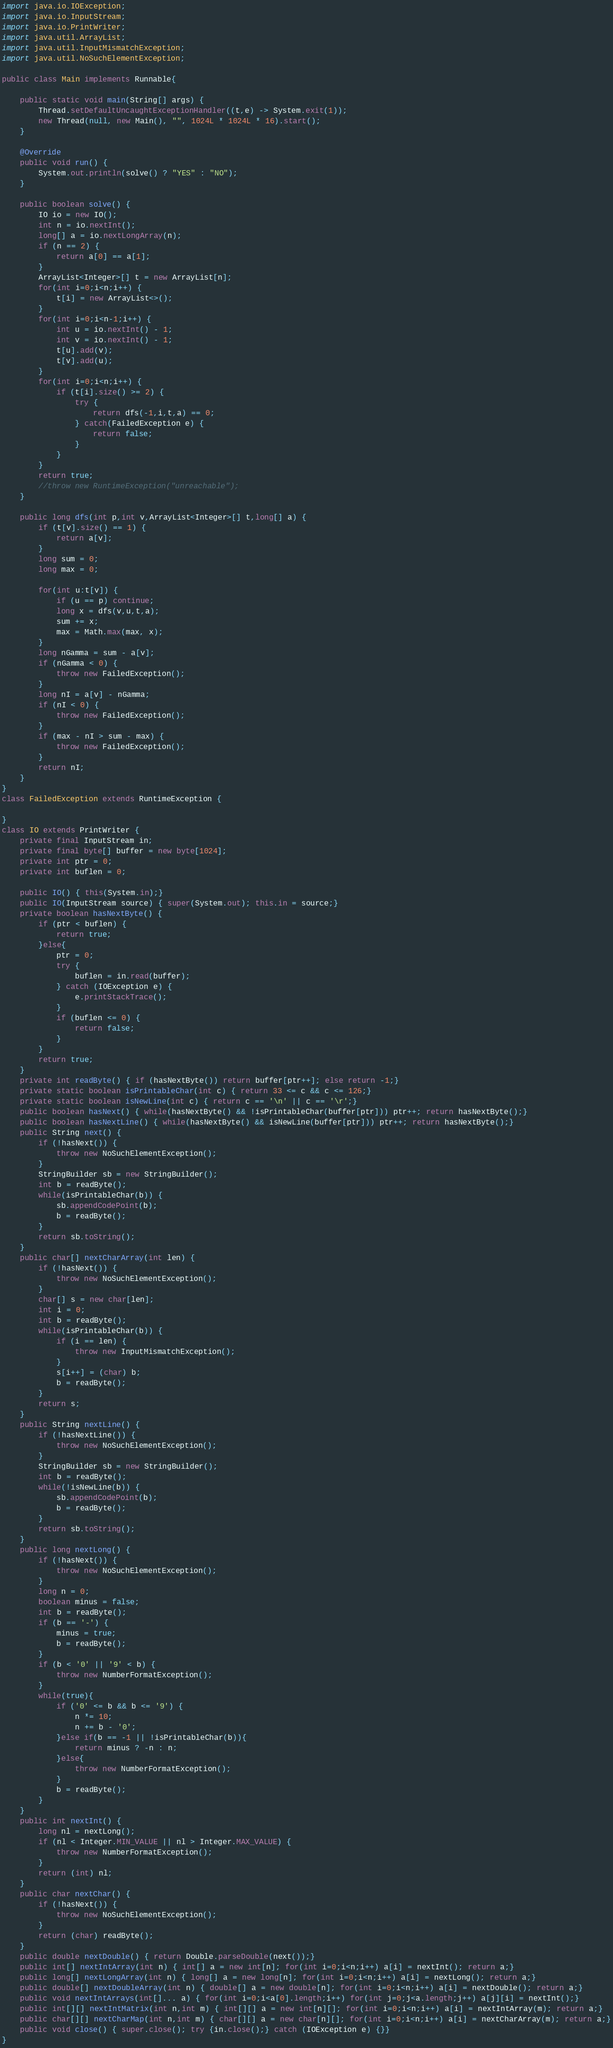<code> <loc_0><loc_0><loc_500><loc_500><_Java_>import java.io.IOException;
import java.io.InputStream;
import java.io.PrintWriter;
import java.util.ArrayList;
import java.util.InputMismatchException;
import java.util.NoSuchElementException;

public class Main implements Runnable{

	public static void main(String[] args) {
		Thread.setDefaultUncaughtExceptionHandler((t,e) -> System.exit(1));
		new Thread(null, new Main(), "", 1024L * 1024L * 16).start();
	}

	@Override
	public void run() {
		System.out.println(solve() ? "YES" : "NO");
	}
	
	public boolean solve() {
		IO io = new IO();
		int n = io.nextInt();
		long[] a = io.nextLongArray(n);
		if (n == 2) {
			return a[0] == a[1];
		}
		ArrayList<Integer>[] t = new ArrayList[n];
		for(int i=0;i<n;i++) {
			t[i] = new ArrayList<>();
		}
		for(int i=0;i<n-1;i++) {
			int u = io.nextInt() - 1;
			int v = io.nextInt() - 1;
			t[u].add(v);
			t[v].add(u);
		}
		for(int i=0;i<n;i++) {
			if (t[i].size() >= 2) {
				try {
					return dfs(-1,i,t,a) == 0;
				} catch(FailedException e) {
					return false;
				}
			}
		}
		return true;
		//throw new RuntimeException("unreachable");
	}
	
	public long dfs(int p,int v,ArrayList<Integer>[] t,long[] a) {
		if (t[v].size() == 1) {
			return a[v];
		}
		long sum = 0;
		long max = 0;
		
		for(int u:t[v]) {
			if (u == p) continue;
			long x = dfs(v,u,t,a);
			sum += x; 
			max = Math.max(max, x);
		}
		long nGamma = sum - a[v];
		if (nGamma < 0) {
			throw new FailedException();
		}
		long nI = a[v] - nGamma;
		if (nI < 0) {
			throw new FailedException();
		}
		if (max - nI > sum - max) {
			throw new FailedException();
		}
		return nI;
	}
}
class FailedException extends RuntimeException {
	
}
class IO extends PrintWriter {
	private final InputStream in;
	private final byte[] buffer = new byte[1024];
	private int ptr = 0;
	private int buflen = 0;
	
	public IO() { this(System.in);}
	public IO(InputStream source) { super(System.out); this.in = source;}
	private boolean hasNextByte() {
		if (ptr < buflen) {
			return true;
		}else{
			ptr = 0;
			try {
				buflen = in.read(buffer);
			} catch (IOException e) {
				e.printStackTrace();
			}
			if (buflen <= 0) {
				return false;
			}
		}
		return true;
	}
	private int readByte() { if (hasNextByte()) return buffer[ptr++]; else return -1;}
	private static boolean isPrintableChar(int c) { return 33 <= c && c <= 126;}
	private static boolean isNewLine(int c) { return c == '\n' || c == '\r';}
	public boolean hasNext() { while(hasNextByte() && !isPrintableChar(buffer[ptr])) ptr++; return hasNextByte();}
	public boolean hasNextLine() { while(hasNextByte() && isNewLine(buffer[ptr])) ptr++; return hasNextByte();}
	public String next() {
		if (!hasNext()) {
			throw new NoSuchElementException();
		}
		StringBuilder sb = new StringBuilder();
		int b = readByte();
		while(isPrintableChar(b)) {
			sb.appendCodePoint(b);
			b = readByte();
		}
		return sb.toString();
	}
	public char[] nextCharArray(int len) {
		if (!hasNext()) {
			throw new NoSuchElementException();
		}
		char[] s = new char[len];
		int i = 0;
		int b = readByte();
		while(isPrintableChar(b)) {
			if (i == len) {
				throw new InputMismatchException();
			}
			s[i++] = (char) b;
			b = readByte();
		}
		return s;
	}
	public String nextLine() {
		if (!hasNextLine()) {
			throw new NoSuchElementException();
		}
		StringBuilder sb = new StringBuilder();
		int b = readByte();
		while(!isNewLine(b)) {
			sb.appendCodePoint(b);
			b = readByte();
		}
		return sb.toString();
	}
	public long nextLong() {
		if (!hasNext()) {
			throw new NoSuchElementException();
		}
		long n = 0;
		boolean minus = false;
		int b = readByte();
		if (b == '-') {
			minus = true;
			b = readByte();
		}
		if (b < '0' || '9' < b) {
			throw new NumberFormatException();
		}
		while(true){
			if ('0' <= b && b <= '9') {
				n *= 10;
				n += b - '0';
			}else if(b == -1 || !isPrintableChar(b)){
				return minus ? -n : n;
			}else{
				throw new NumberFormatException();
			}
			b = readByte();
		}
	}
	public int nextInt() {
		long nl = nextLong();
		if (nl < Integer.MIN_VALUE || nl > Integer.MAX_VALUE) {
			throw new NumberFormatException();
		}
		return (int) nl;
	}
	public char nextChar() {
		if (!hasNext()) {
			throw new NoSuchElementException();
		}
		return (char) readByte();
	}
	public double nextDouble() { return Double.parseDouble(next());}
	public int[] nextIntArray(int n) { int[] a = new int[n]; for(int i=0;i<n;i++) a[i] = nextInt(); return a;}
	public long[] nextLongArray(int n) { long[] a = new long[n]; for(int i=0;i<n;i++) a[i] = nextLong(); return a;}
	public double[] nextDoubleArray(int n) { double[] a = new double[n]; for(int i=0;i<n;i++) a[i] = nextDouble(); return a;}
	public void nextIntArrays(int[]... a) { for(int i=0;i<a[0].length;i++) for(int j=0;j<a.length;j++) a[j][i] = nextInt();}
	public int[][] nextIntMatrix(int n,int m) { int[][] a = new int[n][]; for(int i=0;i<n;i++) a[i] = nextIntArray(m); return a;}
	public char[][] nextCharMap(int n,int m) { char[][] a = new char[n][]; for(int i=0;i<n;i++) a[i] = nextCharArray(m); return a;}
	public void close() { super.close(); try {in.close();} catch (IOException e) {}}
}

</code> 